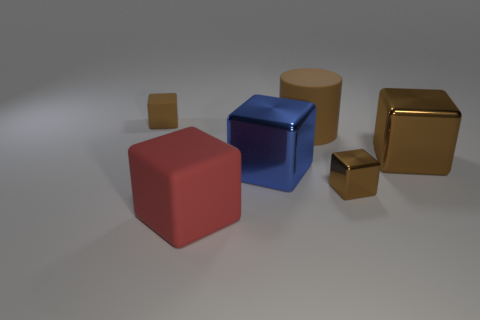There is a big red thing; what shape is it?
Your answer should be compact. Cube. What number of objects are either matte things or big brown cylinders?
Your answer should be compact. 3. Do the matte thing left of the big red rubber thing and the object right of the tiny metal thing have the same size?
Give a very brief answer. No. What number of other things are the same material as the large brown cylinder?
Give a very brief answer. 2. Is the number of blue objects that are in front of the large brown rubber cylinder greater than the number of small metal cubes to the left of the blue metallic block?
Make the answer very short. Yes. There is a tiny block right of the small rubber block; what is it made of?
Provide a short and direct response. Metal. Is the shape of the red matte thing the same as the blue shiny thing?
Provide a succinct answer. Yes. Is there any other thing that is the same color as the large cylinder?
Offer a terse response. Yes. The tiny metallic object that is the same shape as the large brown metallic object is what color?
Offer a terse response. Brown. Are there more large blue shiny cubes that are behind the matte cylinder than small purple rubber spheres?
Your response must be concise. No. 